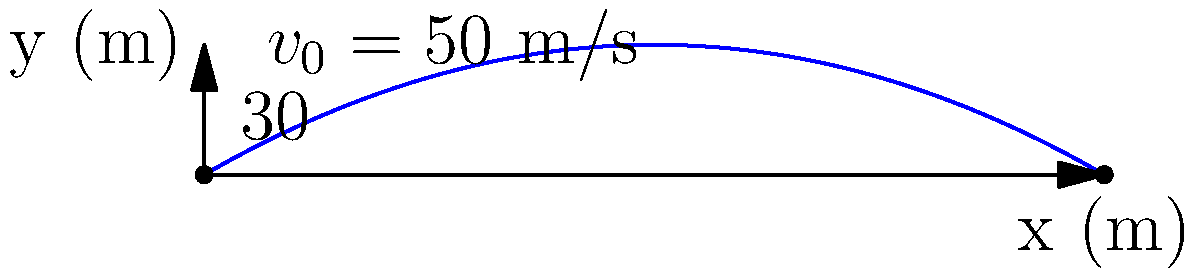As an experienced online learner, you're helping your younger sibling with their physics homework. They need to calculate the maximum horizontal distance traveled by a projectile launched with an initial velocity of 50 m/s at an angle of 30° above the horizontal. Assuming no air resistance, what is the maximum horizontal distance (in meters) the projectile will travel before hitting the ground? To solve this problem, we'll use the equations of motion for projectile motion. Let's break it down step-by-step:

1) First, we need to identify the known variables:
   Initial velocity, $v_0 = 50$ m/s
   Launch angle, $\theta = 30°$
   Acceleration due to gravity, $g = 9.8$ m/s²

2) The maximum horizontal distance is reached when the projectile returns to its initial height (y = 0). The time to reach this point is twice the time to reach the maximum height.

3) To find the time of flight, we use the equation:
   $t_{flight} = \frac{2v_0 \sin \theta}{g}$

4) Substituting the values:
   $t_{flight} = \frac{2 \cdot 50 \cdot \sin 30°}{9.8} = \frac{2 \cdot 50 \cdot 0.5}{9.8} = \frac{50}{9.8} \approx 5.10$ seconds

5) Now, to find the maximum horizontal distance, we use:
   $x_{max} = v_0 \cos \theta \cdot t_{flight}$

6) Substituting the values:
   $x_{max} = 50 \cos 30° \cdot 5.10 = 50 \cdot 0.866 \cdot 5.10 \approx 220.83$ meters

Therefore, the maximum horizontal distance traveled by the projectile is approximately 220.83 meters.
Answer: 220.83 m 